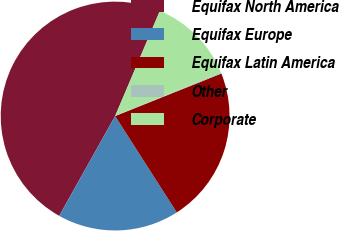Convert chart to OTSL. <chart><loc_0><loc_0><loc_500><loc_500><pie_chart><fcel>Equifax North America<fcel>Equifax Europe<fcel>Equifax Latin America<fcel>Other<fcel>Corporate<nl><fcel>48.28%<fcel>17.19%<fcel>22.0%<fcel>0.17%<fcel>12.37%<nl></chart> 